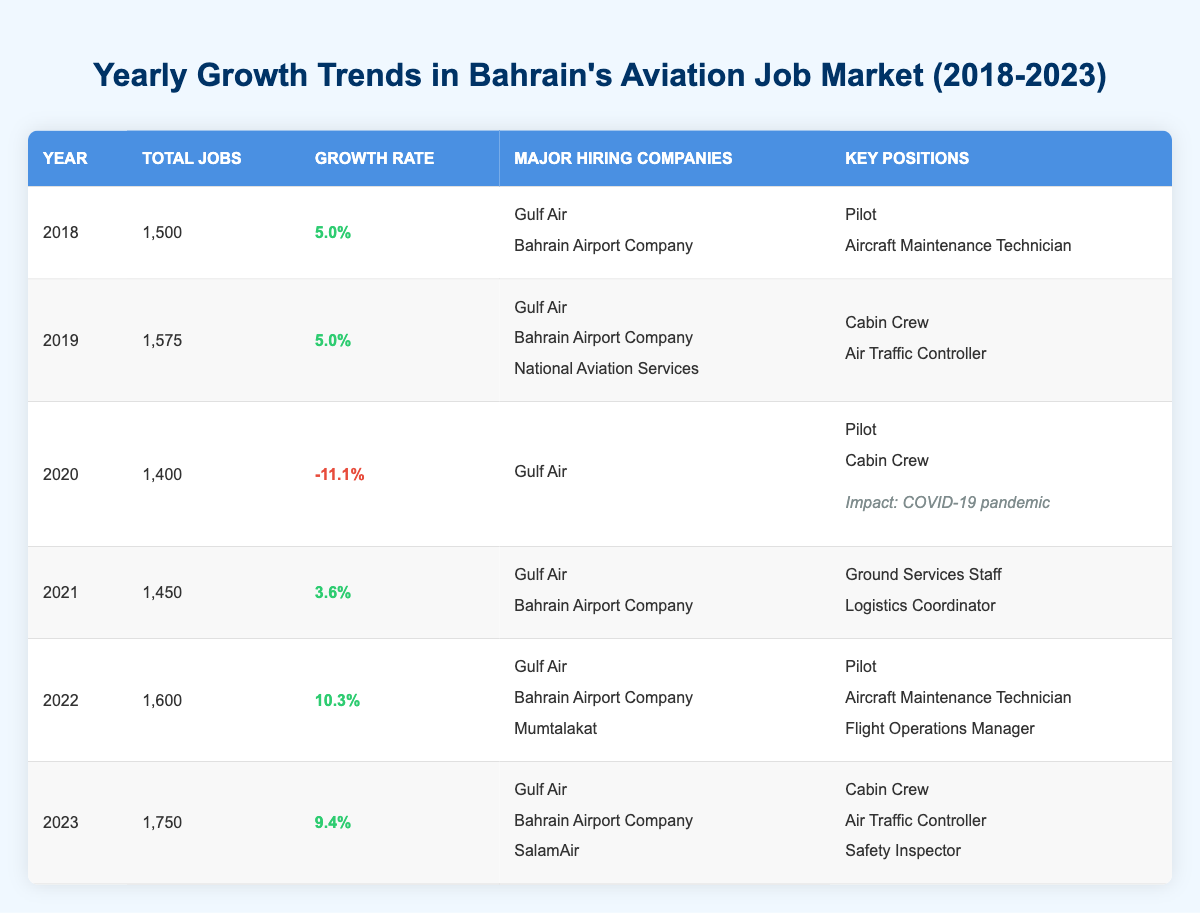What was the total number of jobs in 2022? The table shows that the total number of jobs in the year 2022 is 1,600.
Answer: 1,600 Which year had the highest growth rate? To find the highest growth rate, we compare the growth rates for all years. The highest growth rate is 10.3% in 2022.
Answer: 2022 Did Gulf Air hire for the position of Air Traffic Controller in 2019? The table indicates that in 2019, Gulf Air was a major hiring company, but the key positions mentioned for that year include Cabin Crew and Air Traffic Controller, but it does not confirm Gulf Air hired specifically for that role.
Answer: No What was the average growth rate from 2018 to 2023? The growth rates for the years are 5.0, 5.0, -11.1, 3.6, 10.3, and 9.4. Adding these gives a total of 22.2, and dividing by 6 (the number of years) gives an average of 3.7.
Answer: 3.7 In which year did the job market decline, and what was the decline rate? The job market declined in 2020, with a growth rate of -11.1%, indicating a decrease in jobs that year.
Answer: 2020, -11.1% How many major hiring companies were involved in 2023? In 2023, three major hiring companies are listed: Gulf Air, Bahrain Airport Company, and SalamAir.
Answer: 3 Was there a negative growth rate in the years listed? Yes, the table shows a negative growth rate in 2020, which was -11.1%, indicating a decline in the job market that year.
Answer: Yes What positions were key hires for Gulf Air in 2021? The table states that in 2021, the key positions for Gulf Air were Ground Services Staff and Logistics Coordinator.
Answer: Ground Services Staff, Logistics Coordinator What was the total job count in 2023 compared to 2020? In 2023, the total jobs are 1,750, while in 2020 it was 1,400. The difference is 1,750 - 1,400 = 350 more jobs in 2023.
Answer: 350 more jobs 